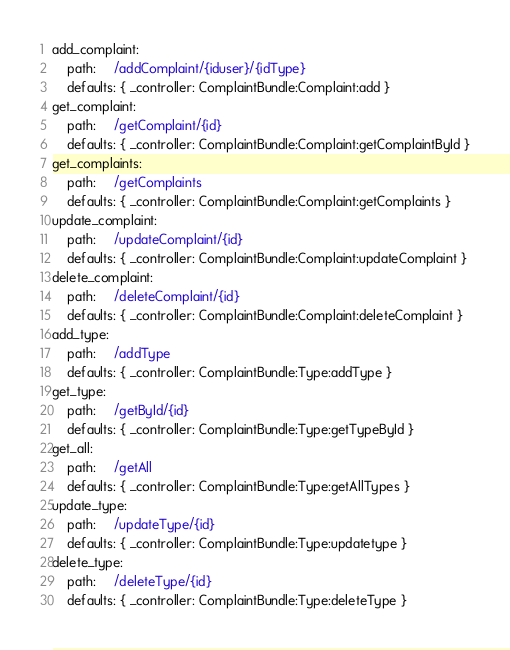<code> <loc_0><loc_0><loc_500><loc_500><_YAML_>add_complaint:
    path:     /addComplaint/{iduser}/{idType}
    defaults: { _controller: ComplaintBundle:Complaint:add }
get_complaint:
    path:     /getComplaint/{id}
    defaults: { _controller: ComplaintBundle:Complaint:getComplaintById }
get_complaints:
    path:     /getComplaints
    defaults: { _controller: ComplaintBundle:Complaint:getComplaints }
update_complaint:
    path:     /updateComplaint/{id}
    defaults: { _controller: ComplaintBundle:Complaint:updateComplaint }
delete_complaint:
    path:     /deleteComplaint/{id}
    defaults: { _controller: ComplaintBundle:Complaint:deleteComplaint }
add_type:
    path:     /addType
    defaults: { _controller: ComplaintBundle:Type:addType }
get_type:
    path:     /getById/{id}
    defaults: { _controller: ComplaintBundle:Type:getTypeById }
get_all:
    path:     /getAll
    defaults: { _controller: ComplaintBundle:Type:getAllTypes }
update_type:
    path:     /updateType/{id}
    defaults: { _controller: ComplaintBundle:Type:updatetype }
delete_type:
    path:     /deleteType/{id}
    defaults: { _controller: ComplaintBundle:Type:deleteType }</code> 